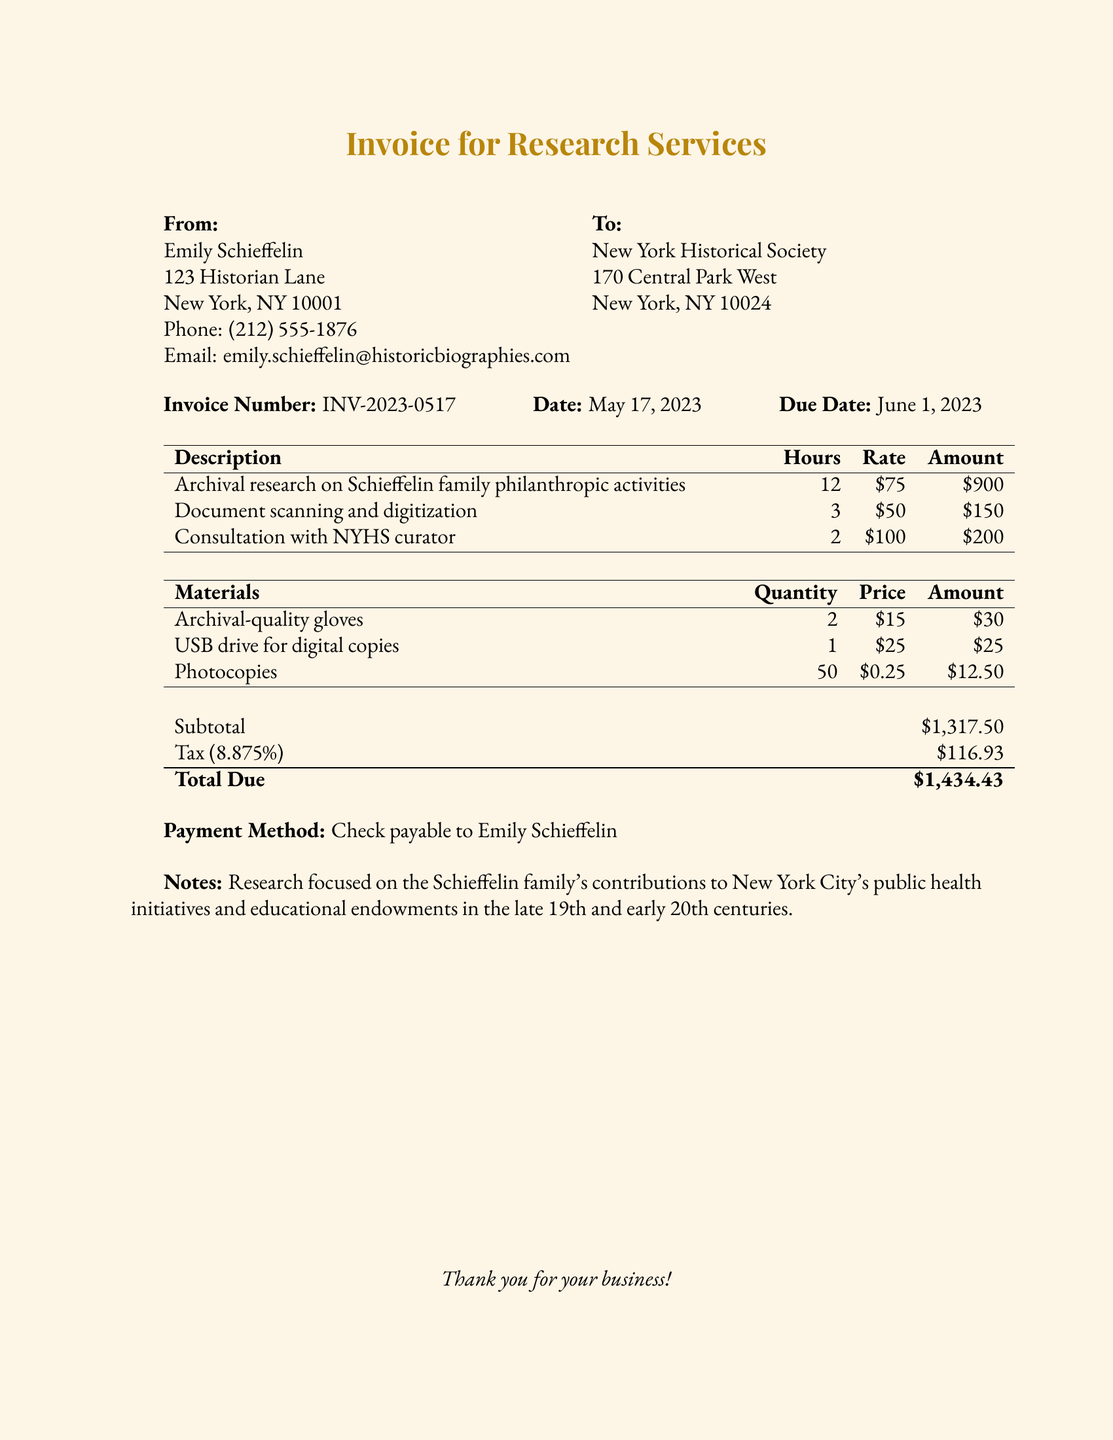What is the invoice number? The invoice number is stated clearly in the document as INV-2023-0517.
Answer: INV-2023-0517 What is the total amount due? The total amount due is provided at the end of the document, showing the overall cost including tax.
Answer: $1,434.43 Who is the invoice from? The invoice lists Emily Schieffelin as the sender.
Answer: Emily Schieffelin How many hours were spent on archival research? The document specifies that 12 hours were dedicated to archival research on the Schieffelin family.
Answer: 12 What is the rate for consultation with the NYHS curator? The rate for consultation is explicitly mentioned in the invoice.
Answer: $100 What materials were used in the research? The document lists archival-quality gloves, a USB drive, and photocopies as materials used.
Answer: Archival-quality gloves, USB drive, Photocopies What percentage is the tax applied to the subtotal? The tax percentage is indicated as 8.875% in the document.
Answer: 8.875% What is the due date for the invoice payment? The due date is mentioned in the document as June 1, 2023.
Answer: June 1, 2023 What was the purpose of the research conducted? The document notes that the research focused on the Schieffelin family's contributions to public health initiatives and educational endowments.
Answer: Contributions to public health initiatives and educational endowments 